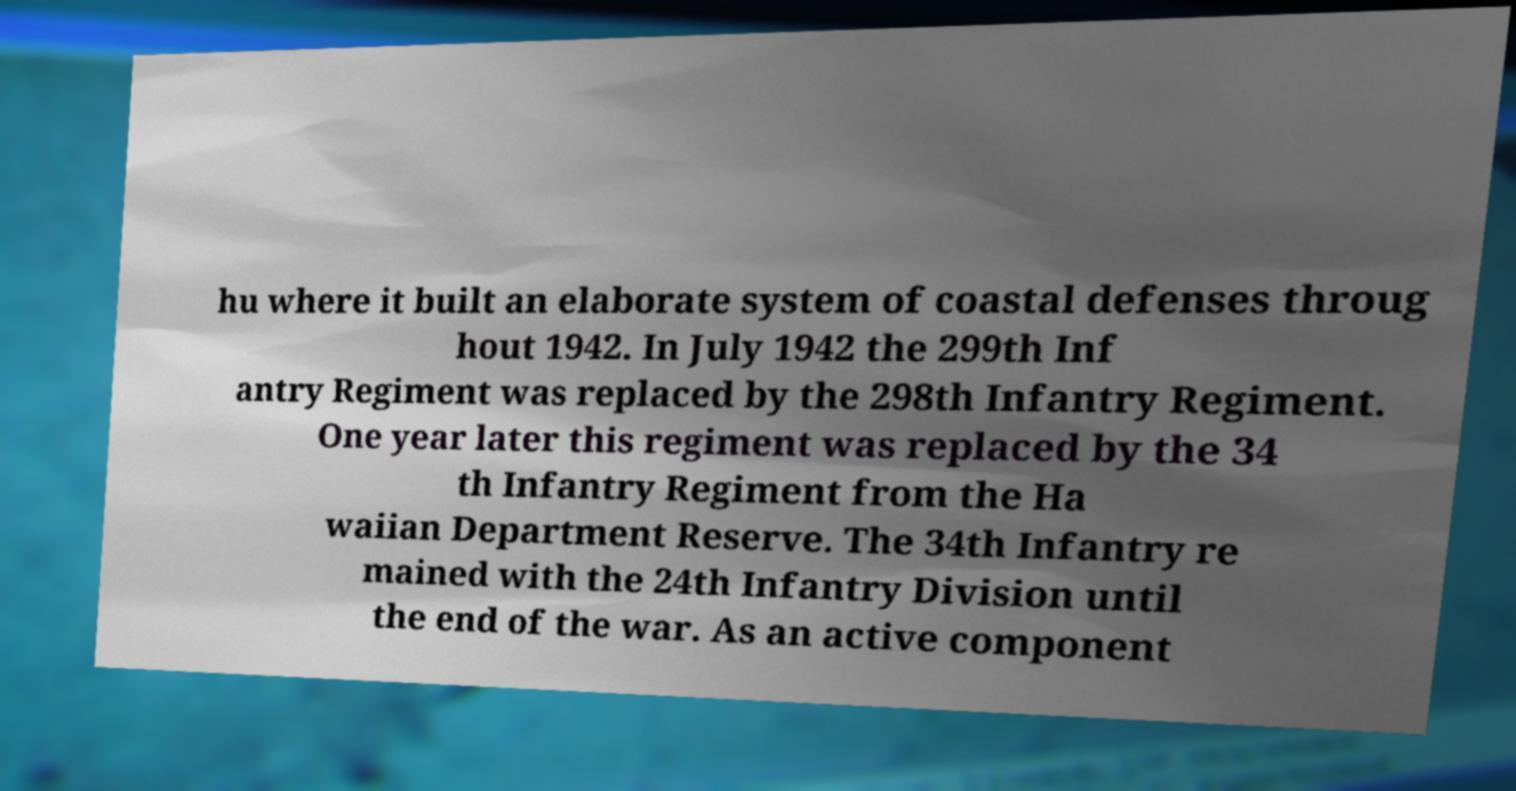Can you read and provide the text displayed in the image?This photo seems to have some interesting text. Can you extract and type it out for me? hu where it built an elaborate system of coastal defenses throug hout 1942. In July 1942 the 299th Inf antry Regiment was replaced by the 298th Infantry Regiment. One year later this regiment was replaced by the 34 th Infantry Regiment from the Ha waiian Department Reserve. The 34th Infantry re mained with the 24th Infantry Division until the end of the war. As an active component 